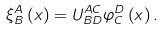Convert formula to latex. <formula><loc_0><loc_0><loc_500><loc_500>\xi _ { B } ^ { A } \left ( x \right ) = U _ { B D } ^ { A C } \varphi _ { C } ^ { D } \left ( x \right ) .</formula> 